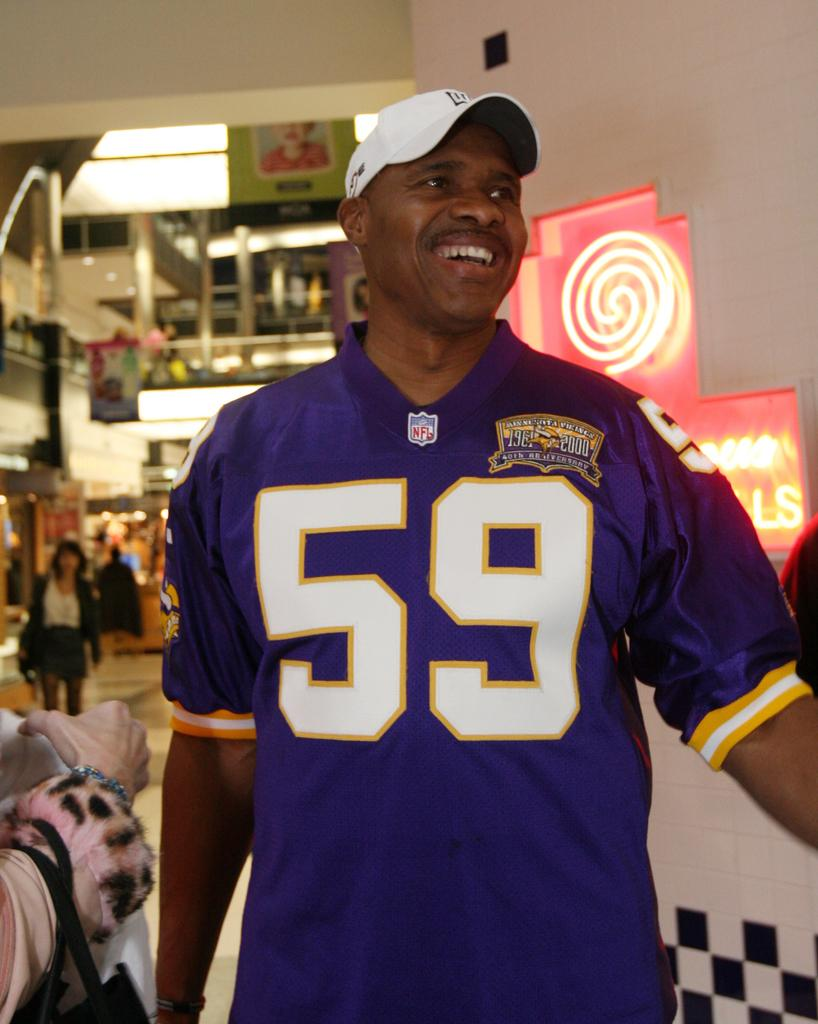<image>
Write a terse but informative summary of the picture. Man wearing a purple jersey with the number 59. 